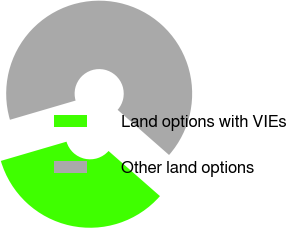Convert chart to OTSL. <chart><loc_0><loc_0><loc_500><loc_500><pie_chart><fcel>Land options with VIEs<fcel>Other land options<nl><fcel>34.0%<fcel>66.0%<nl></chart> 